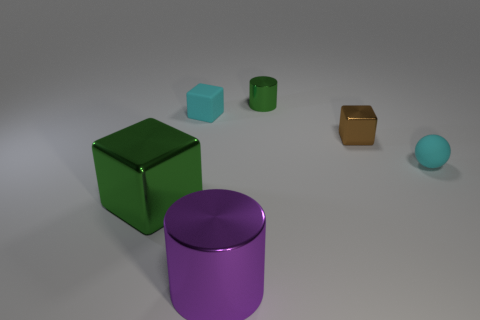Subtract all tiny blocks. How many blocks are left? 1 Add 1 green shiny things. How many objects exist? 7 Subtract all cyan cubes. How many cubes are left? 2 Subtract 2 cylinders. How many cylinders are left? 0 Add 6 tiny green metal cylinders. How many tiny green metal cylinders exist? 7 Subtract 0 red balls. How many objects are left? 6 Subtract all spheres. How many objects are left? 5 Subtract all gray balls. Subtract all yellow cylinders. How many balls are left? 1 Subtract all purple cubes. How many yellow spheres are left? 0 Subtract all gray cylinders. Subtract all brown objects. How many objects are left? 5 